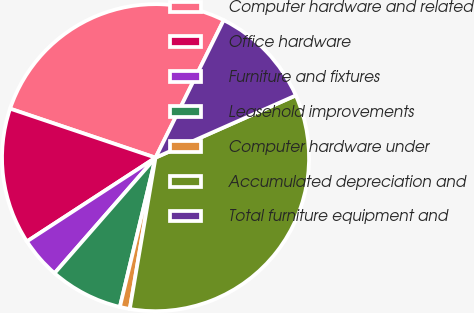<chart> <loc_0><loc_0><loc_500><loc_500><pie_chart><fcel>Computer hardware and related<fcel>Office hardware<fcel>Furniture and fixtures<fcel>Leasehold improvements<fcel>Computer hardware under<fcel>Accumulated depreciation and<fcel>Total furniture equipment and<nl><fcel>27.15%<fcel>14.36%<fcel>4.38%<fcel>7.7%<fcel>1.05%<fcel>34.33%<fcel>11.03%<nl></chart> 